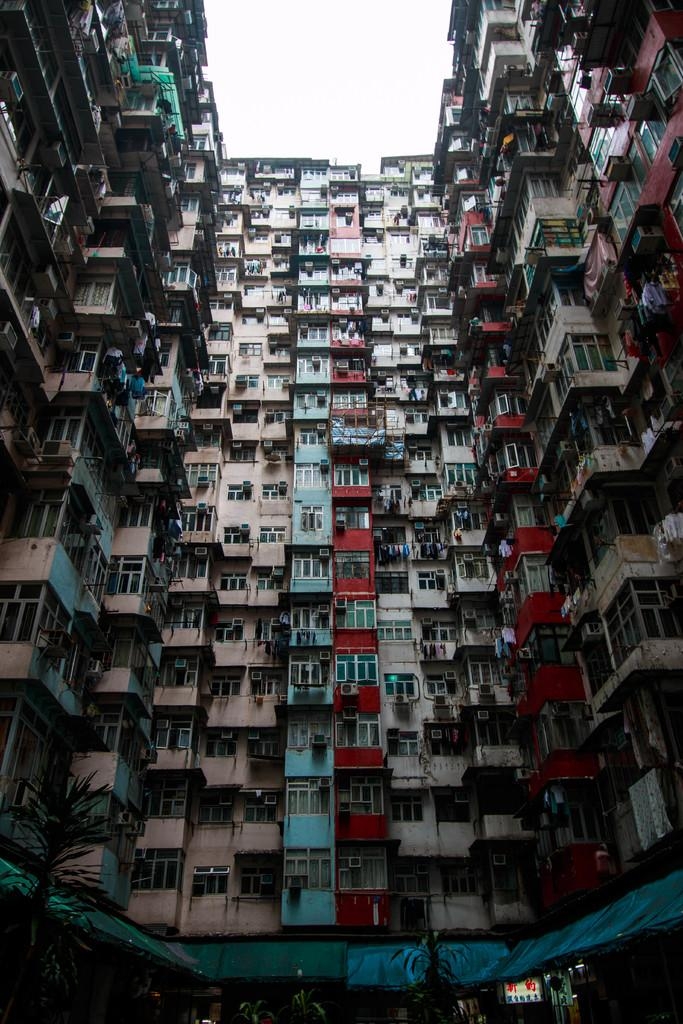What type of structure is in the foreground of the image? There is a building with windows in the foreground of the image. How would you describe the appearance of the building? The building resembles a shed. Are there any plants visible in the image? Yes, there are potted plants at the bottom of the building. What type of humor can be found in the prose written on the building? There is no prose or humor present on the building in the image. 